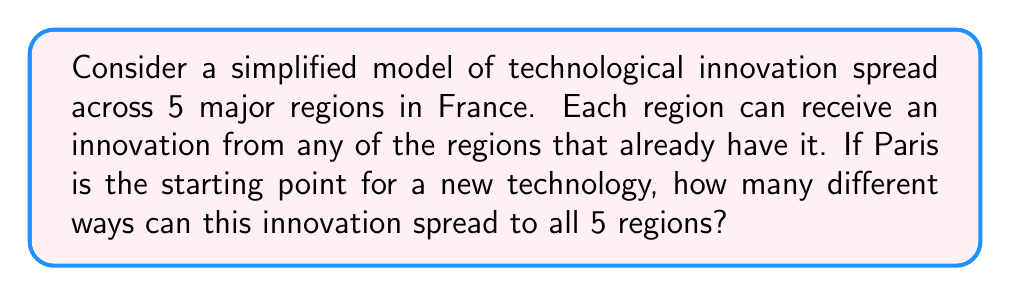What is the answer to this math problem? Let's approach this step-by-step:

1) We have 5 regions, with Paris as the starting point. This means we need to determine the order in which the other 4 regions receive the innovation.

2) This is a permutation problem. We're essentially arranging 4 regions in all possible orders.

3) The number of permutations of n distinct objects is given by $n!$

4) In this case, $n = 4$ (the number of regions excluding Paris)

5) Therefore, the number of ways the innovation can spread is:

   $4! = 4 \times 3 \times 2 \times 1 = 24$

6) We can also express this using the permutation notation:

   $P(4,4) = \frac{4!}{(4-4)!} = \frac{4!}{0!} = 24$

   Note: $0! = 1$ by definition.

This result means there are 24 different possible paths for the technology to spread from Paris to the other 4 regions.
Answer: 24 